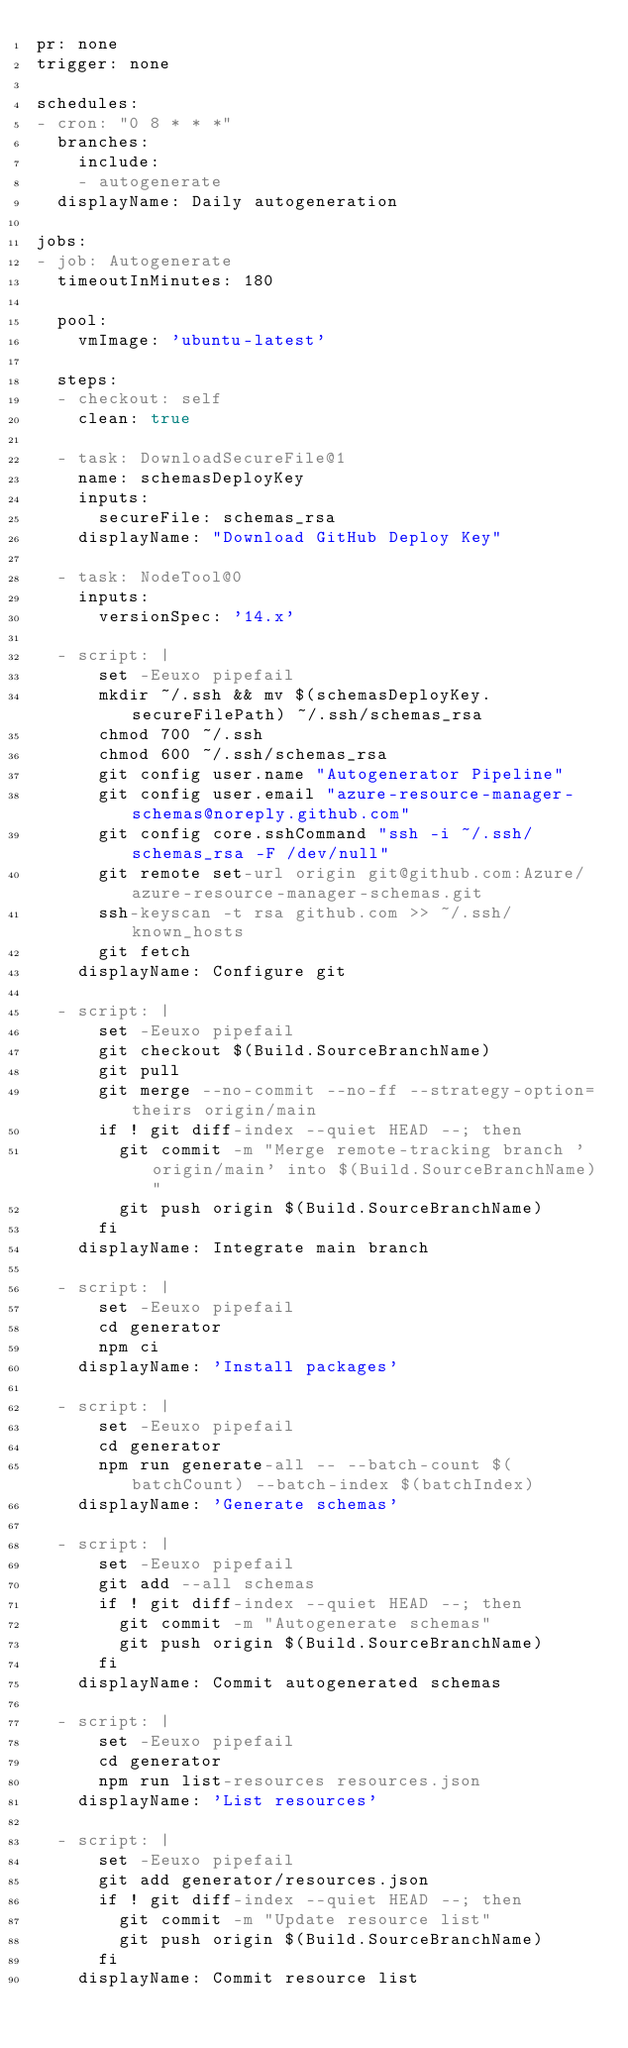Convert code to text. <code><loc_0><loc_0><loc_500><loc_500><_YAML_>pr: none
trigger: none

schedules:
- cron: "0 8 * * *"
  branches:
    include:
    - autogenerate
  displayName: Daily autogeneration

jobs:
- job: Autogenerate
  timeoutInMinutes: 180

  pool:
    vmImage: 'ubuntu-latest'

  steps:
  - checkout: self
    clean: true

  - task: DownloadSecureFile@1
    name: schemasDeployKey
    inputs:
      secureFile: schemas_rsa
    displayName: "Download GitHub Deploy Key"
  
  - task: NodeTool@0
    inputs:
      versionSpec: '14.x'

  - script: |
      set -Eeuxo pipefail
      mkdir ~/.ssh && mv $(schemasDeployKey.secureFilePath) ~/.ssh/schemas_rsa
      chmod 700 ~/.ssh
      chmod 600 ~/.ssh/schemas_rsa
      git config user.name "Autogenerator Pipeline"
      git config user.email "azure-resource-manager-schemas@noreply.github.com"
      git config core.sshCommand "ssh -i ~/.ssh/schemas_rsa -F /dev/null"
      git remote set-url origin git@github.com:Azure/azure-resource-manager-schemas.git
      ssh-keyscan -t rsa github.com >> ~/.ssh/known_hosts
      git fetch
    displayName: Configure git

  - script: |
      set -Eeuxo pipefail
      git checkout $(Build.SourceBranchName)
      git pull
      git merge --no-commit --no-ff --strategy-option=theirs origin/main
      if ! git diff-index --quiet HEAD --; then
        git commit -m "Merge remote-tracking branch 'origin/main' into $(Build.SourceBranchName)"
        git push origin $(Build.SourceBranchName)
      fi
    displayName: Integrate main branch

  - script: |
      set -Eeuxo pipefail
      cd generator
      npm ci
    displayName: 'Install packages'

  - script: |
      set -Eeuxo pipefail
      cd generator
      npm run generate-all -- --batch-count $(batchCount) --batch-index $(batchIndex)
    displayName: 'Generate schemas'

  - script: |
      set -Eeuxo pipefail
      git add --all schemas
      if ! git diff-index --quiet HEAD --; then
        git commit -m "Autogenerate schemas"
        git push origin $(Build.SourceBranchName)
      fi
    displayName: Commit autogenerated schemas

  - script: |
      set -Eeuxo pipefail
      cd generator
      npm run list-resources resources.json
    displayName: 'List resources'

  - script: |
      set -Eeuxo pipefail
      git add generator/resources.json
      if ! git diff-index --quiet HEAD --; then
        git commit -m "Update resource list"
        git push origin $(Build.SourceBranchName)
      fi
    displayName: Commit resource list
</code> 